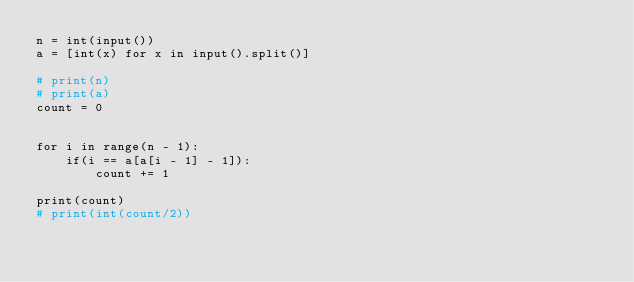Convert code to text. <code><loc_0><loc_0><loc_500><loc_500><_Python_>n = int(input())
a = [int(x) for x in input().split()]

# print(n)
# print(a)
count = 0


for i in range(n - 1):
    if(i == a[a[i - 1] - 1]):
        count += 1

print(count)
# print(int(count/2))
</code> 